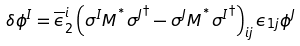<formula> <loc_0><loc_0><loc_500><loc_500>\delta \phi ^ { I } = \overline { \epsilon } _ { 2 } ^ { i } \left ( \sigma ^ { I } M ^ { ^ { * } } { \sigma ^ { J } } ^ { \dagger } - \sigma ^ { J } M ^ { ^ { * } } { \sigma ^ { I } } ^ { \dagger } \right ) _ { i j } \epsilon _ { 1 j } \phi ^ { J }</formula> 